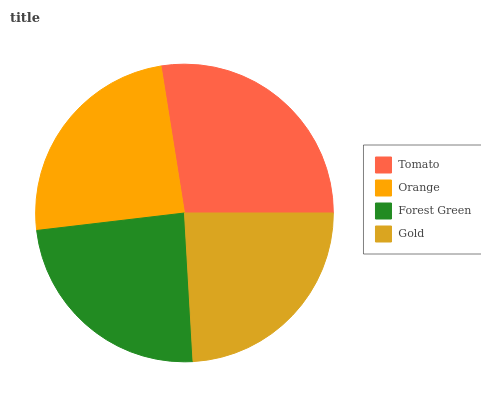Is Forest Green the minimum?
Answer yes or no. Yes. Is Tomato the maximum?
Answer yes or no. Yes. Is Orange the minimum?
Answer yes or no. No. Is Orange the maximum?
Answer yes or no. No. Is Tomato greater than Orange?
Answer yes or no. Yes. Is Orange less than Tomato?
Answer yes or no. Yes. Is Orange greater than Tomato?
Answer yes or no. No. Is Tomato less than Orange?
Answer yes or no. No. Is Orange the high median?
Answer yes or no. Yes. Is Gold the low median?
Answer yes or no. Yes. Is Gold the high median?
Answer yes or no. No. Is Tomato the low median?
Answer yes or no. No. 